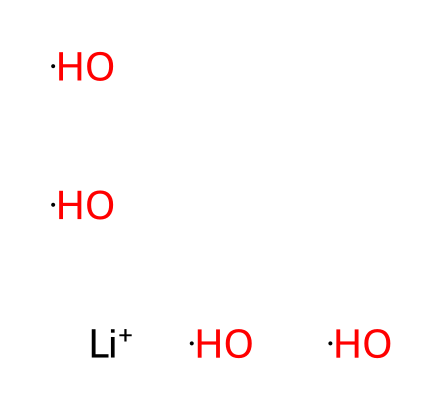What elements are present in this chemical? The SMILES representation shows [Li+] which indicates lithium, and there are instances of [O] and [H], indicating the presence of oxygen and hydrogen. Thus, the elements present are lithium, oxygen, and hydrogen.
Answer: lithium, oxygen, hydrogen How many water molecules are associated with the lithium ion? In the chemical structure, there are four [O][H] groups, which represents four water molecules (H2O). Each group consists of one oxygen and two hydrogens, thus indicating four water molecules.
Answer: four What charge does the lithium ion carry? The symbol [Li+] in the SMILES indicates that lithium has a single positive charge. The plus sign denotes the positive charge associated with the ion.
Answer: positive What is the overall molecular geometry of the hydrated lithium ion? The SMILES indicates that the hydrated lithium ion is surrounded by four water molecules, suggesting a tetrahedral geometry around the lithium ion due to the arrangement of the oxygen atoms from the water molecules.
Answer: tetrahedral How does the presence of water molecules affect the stability of the lithium ion? The solvation of lithium ions (due to hydration) stabilizes the ion, as the polar nature of water molecules surrounds the lithium ion, reducing its reactivity and promoting its dissolution in solution.
Answer: stabilizes What role does the hydrated lithium ion play in sports drinks? Hydrated lithium ions in sports drinks act as electrolytes, which are essential for maintaining fluid balance, muscle function, and nerve transmission in the body, particularly during physical activities.
Answer: electrolytes What is the total number of atoms in the hydrated lithium ion complex? In the representation, there is one lithium atom, four oxygen atoms, and eight hydrogen atoms (from the four water molecules). The total sums up to 13 atoms (1 + 4 + 8).
Answer: thirteen 